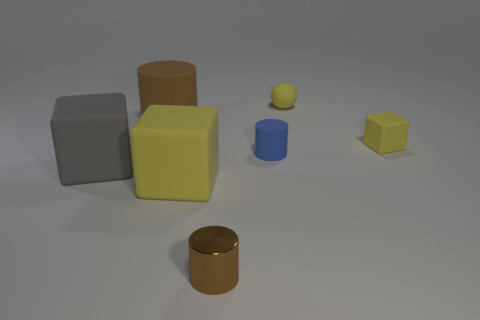How big is the metallic cylinder? The metallic cylinder appears to be small in size, roughly measuring about a quarter of the height of the yellow cube next to it, which gives a sense of scale relative to the other objects in the image. 